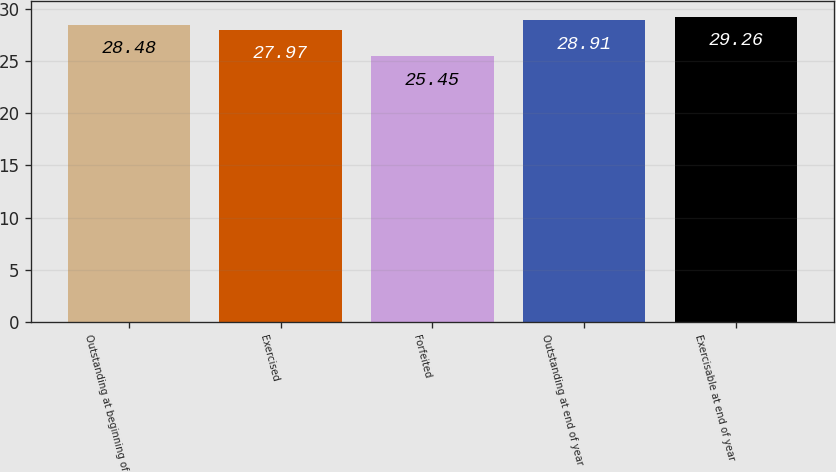Convert chart to OTSL. <chart><loc_0><loc_0><loc_500><loc_500><bar_chart><fcel>Outstanding at beginning of<fcel>Exercised<fcel>Forfeited<fcel>Outstanding at end of year<fcel>Exercisable at end of year<nl><fcel>28.48<fcel>27.97<fcel>25.45<fcel>28.91<fcel>29.26<nl></chart> 